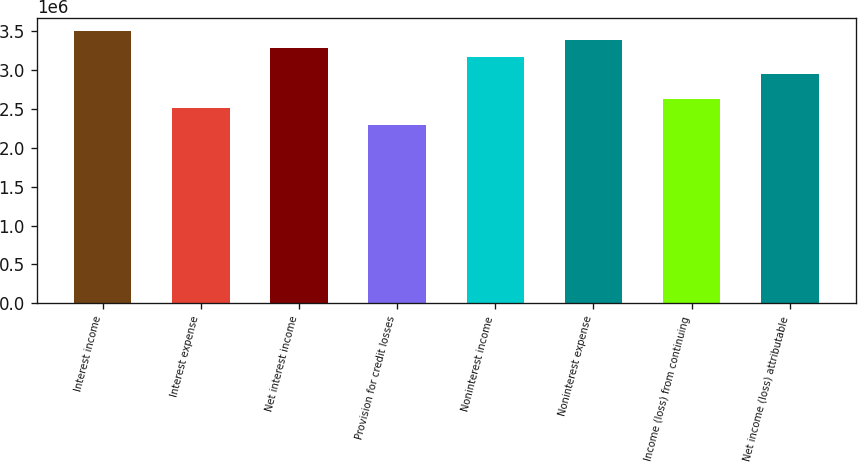<chart> <loc_0><loc_0><loc_500><loc_500><bar_chart><fcel>Interest income<fcel>Interest expense<fcel>Net interest income<fcel>Provision for credit losses<fcel>Noninterest income<fcel>Noninterest expense<fcel>Income (loss) from continuing<fcel>Net income (loss) attributable<nl><fcel>3.49772e+06<fcel>2.51399e+06<fcel>3.27912e+06<fcel>2.29538e+06<fcel>3.16981e+06<fcel>3.38842e+06<fcel>2.62329e+06<fcel>2.95121e+06<nl></chart> 